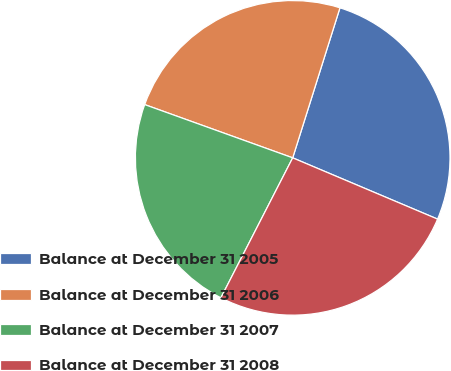Convert chart to OTSL. <chart><loc_0><loc_0><loc_500><loc_500><pie_chart><fcel>Balance at December 31 2005<fcel>Balance at December 31 2006<fcel>Balance at December 31 2007<fcel>Balance at December 31 2008<nl><fcel>26.51%<fcel>24.36%<fcel>22.95%<fcel>26.18%<nl></chart> 